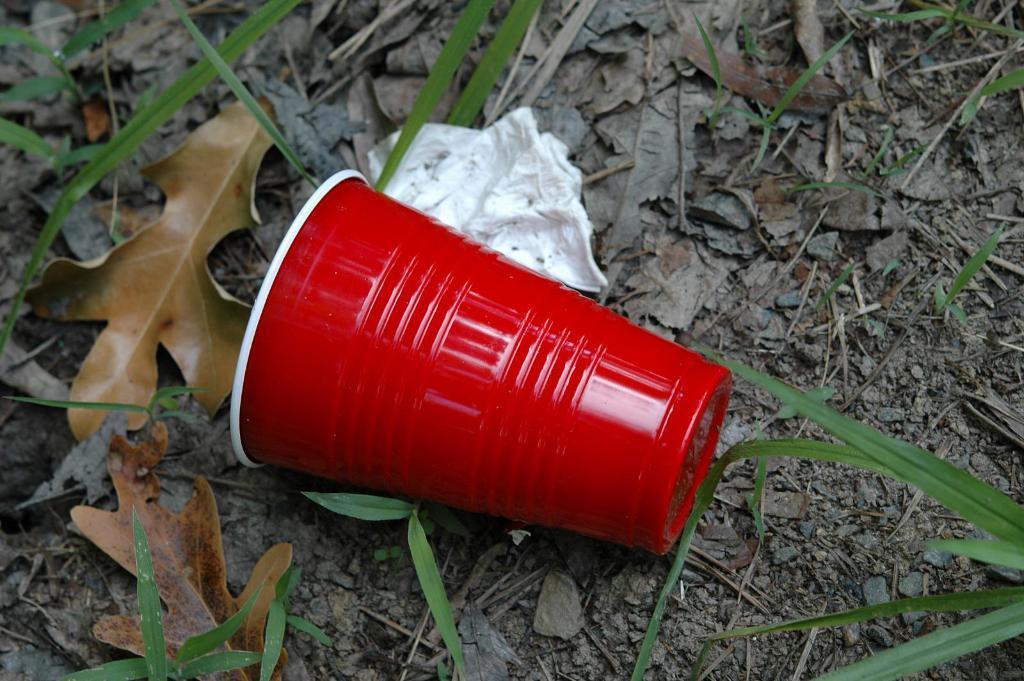How would you summarize this image in a sentence or two? In this picture we can see a glass and tissue paper, at the bottom there are some leaves. 